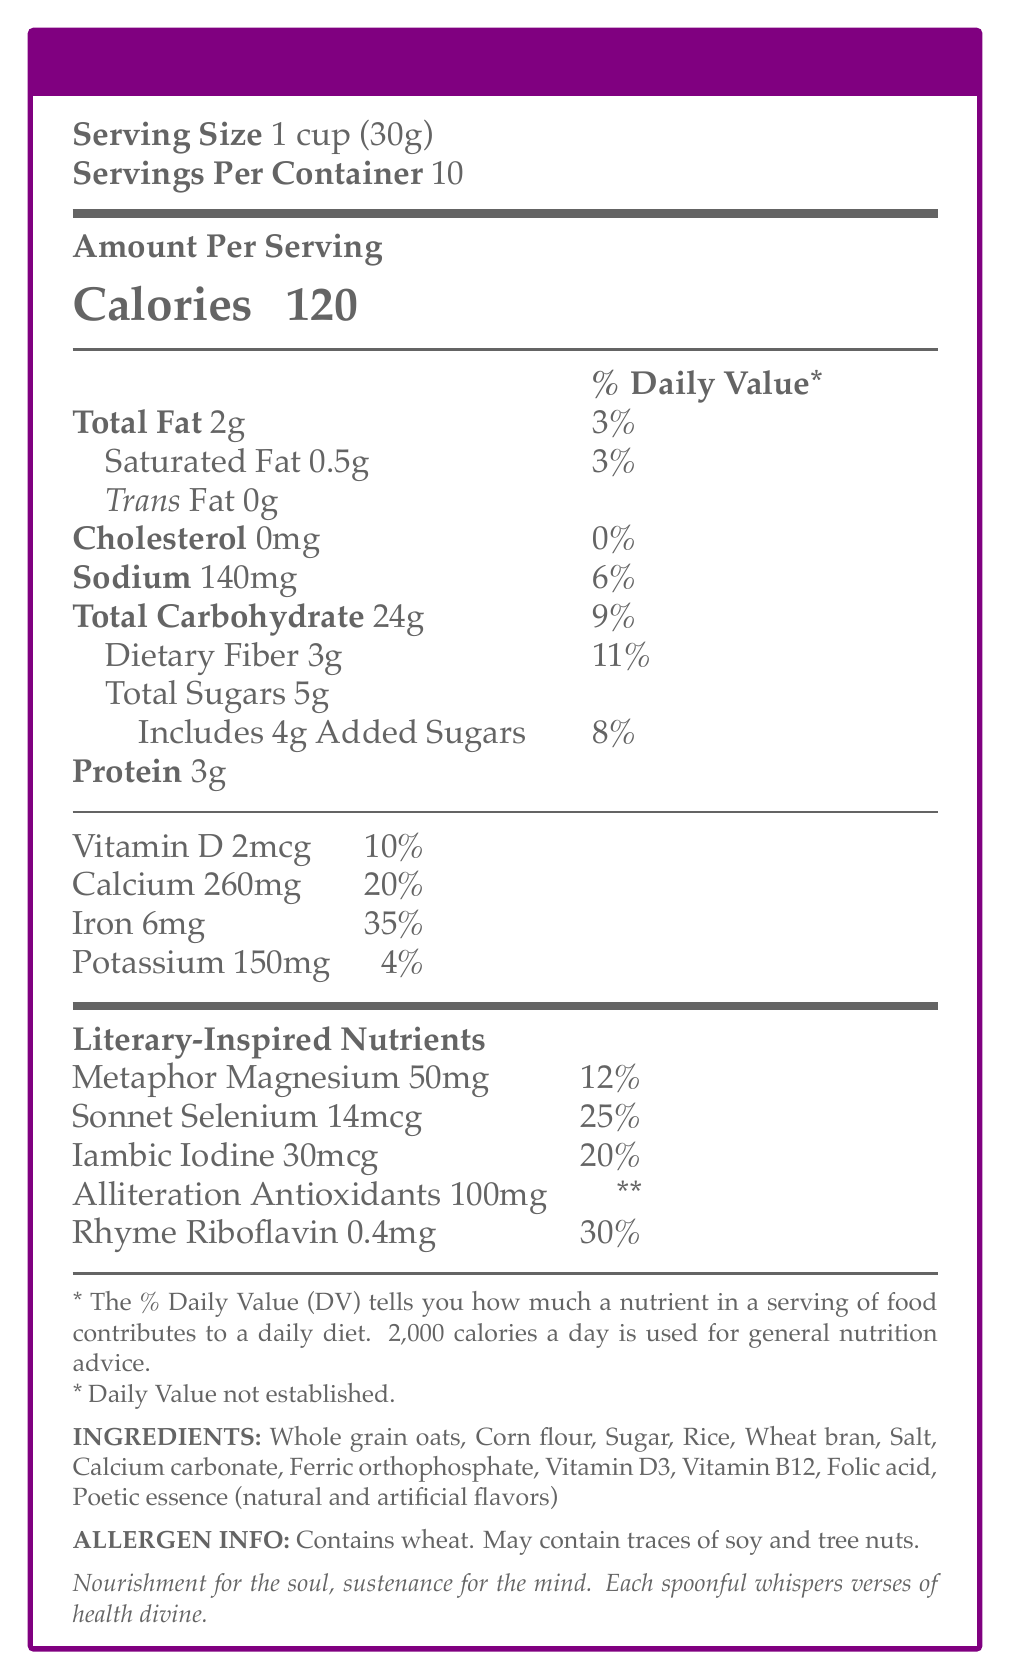what is the serving size? The document specifies "Serving Size" as 1 cup (30g).
Answer: 1 cup (30g) how many servings are there per container? The document mentions "Servings Per Container" as 10.
Answer: 10 what is the calorie content per serving? The document states "Calories" as 120 per serving.
Answer: 120 Calories how much sodium does one serving contain? The document notes "Sodium" amount as 140mg per serving.
Answer: 140mg which vitamins and minerals in the cereal contribute the most to the daily value percentage? The document lists Iron as 35% and Calcium as 20% in the "% Daily Value" section.
Answer: Iron and Calcium what is the percentage of daily value for total fat? Total Fat has a daily value percentage of 3%, as shown in the document.
Answer: 3% which of the following is NOT an ingredient in "Poetic Sustenance" cereal? A. Whole grain oats B. Rice C. Peanuts D. Salt The ingredient list does not include peanuts.
Answer: C. Peanuts what is the total amount of sugars per serving? A. 3g B. 4g C. 5g D. 6g The document lists "Total Sugars" as 5g.
Answer: C. 5g does the cereal contain any trans fat? The document specifies "Trans Fat" as 0g.
Answer: No summarize the main idea of the document The document includes information on serving size, servings per container, calories, fats, cholesterol, sodium, carbohydrates, proteins, vitamins, minerals, literary-inspired nutrients, ingredients, and allergen warning. It aims to show the nutritional profile and unique aspects of the cereal.
Answer: The document provides a detailed nutritional breakdown of "Poetic Sustenance" cereal, including standard nutrients and literary-inspired vitamins and minerals, and highlights ingredients and allergen information. does the cereal contain any allergens? The document mentions that it contains wheat and may contain traces of soy and tree nuts.
Answer: Yes what is the amount of "Sonnet Selenium" per serving? The document specifies "Sonnet Selenium" as 14mcg per serving.
Answer: 14mcg is calcium listed among the literary-inspired nutrients? Calcium is not listed among the literary-inspired nutrients; it is listed among the regular minerals.
Answer: No which nutrient has the highest percentage of daily value? A. Vitamin D B. Calcium C. Iron D. Rhyme Riboflavin The document lists Iron as having a 35% daily value, which is the highest.
Answer: C. Iron how much dietary fiber is in one serving of the cereal? The document lists "Dietary Fiber" as 3g per serving.
Answer: 3g can you determine the exact quantity of metaphors in this cereal? The concept of "Metaphor Magnesium" is a playful, literary-inspired naming and does not represent actual metaphors.
Answer: Not enough information what poetic disclaimer does the document include? The document includes this poetic disclaimer near the end.
Answer: Nourishment for the soul, sustenance for the mind. Each spoonful whispers verses of health divine. how many grams of added sugars are there per serving? The document mentions "Includes 4g Added Sugars."
Answer: 4g 